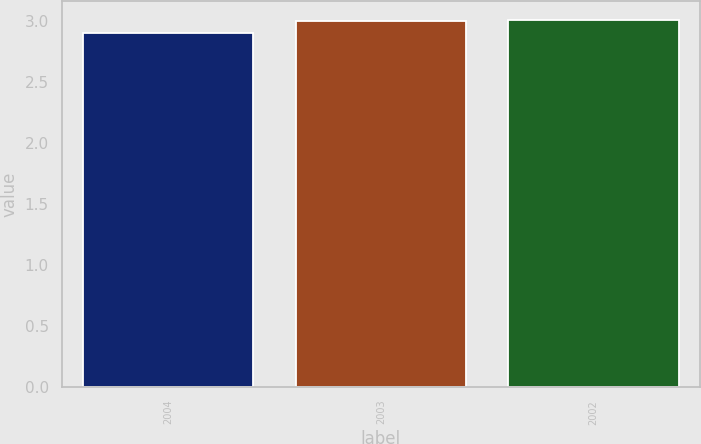<chart> <loc_0><loc_0><loc_500><loc_500><bar_chart><fcel>2004<fcel>2003<fcel>2002<nl><fcel>2.9<fcel>3<fcel>3.01<nl></chart> 